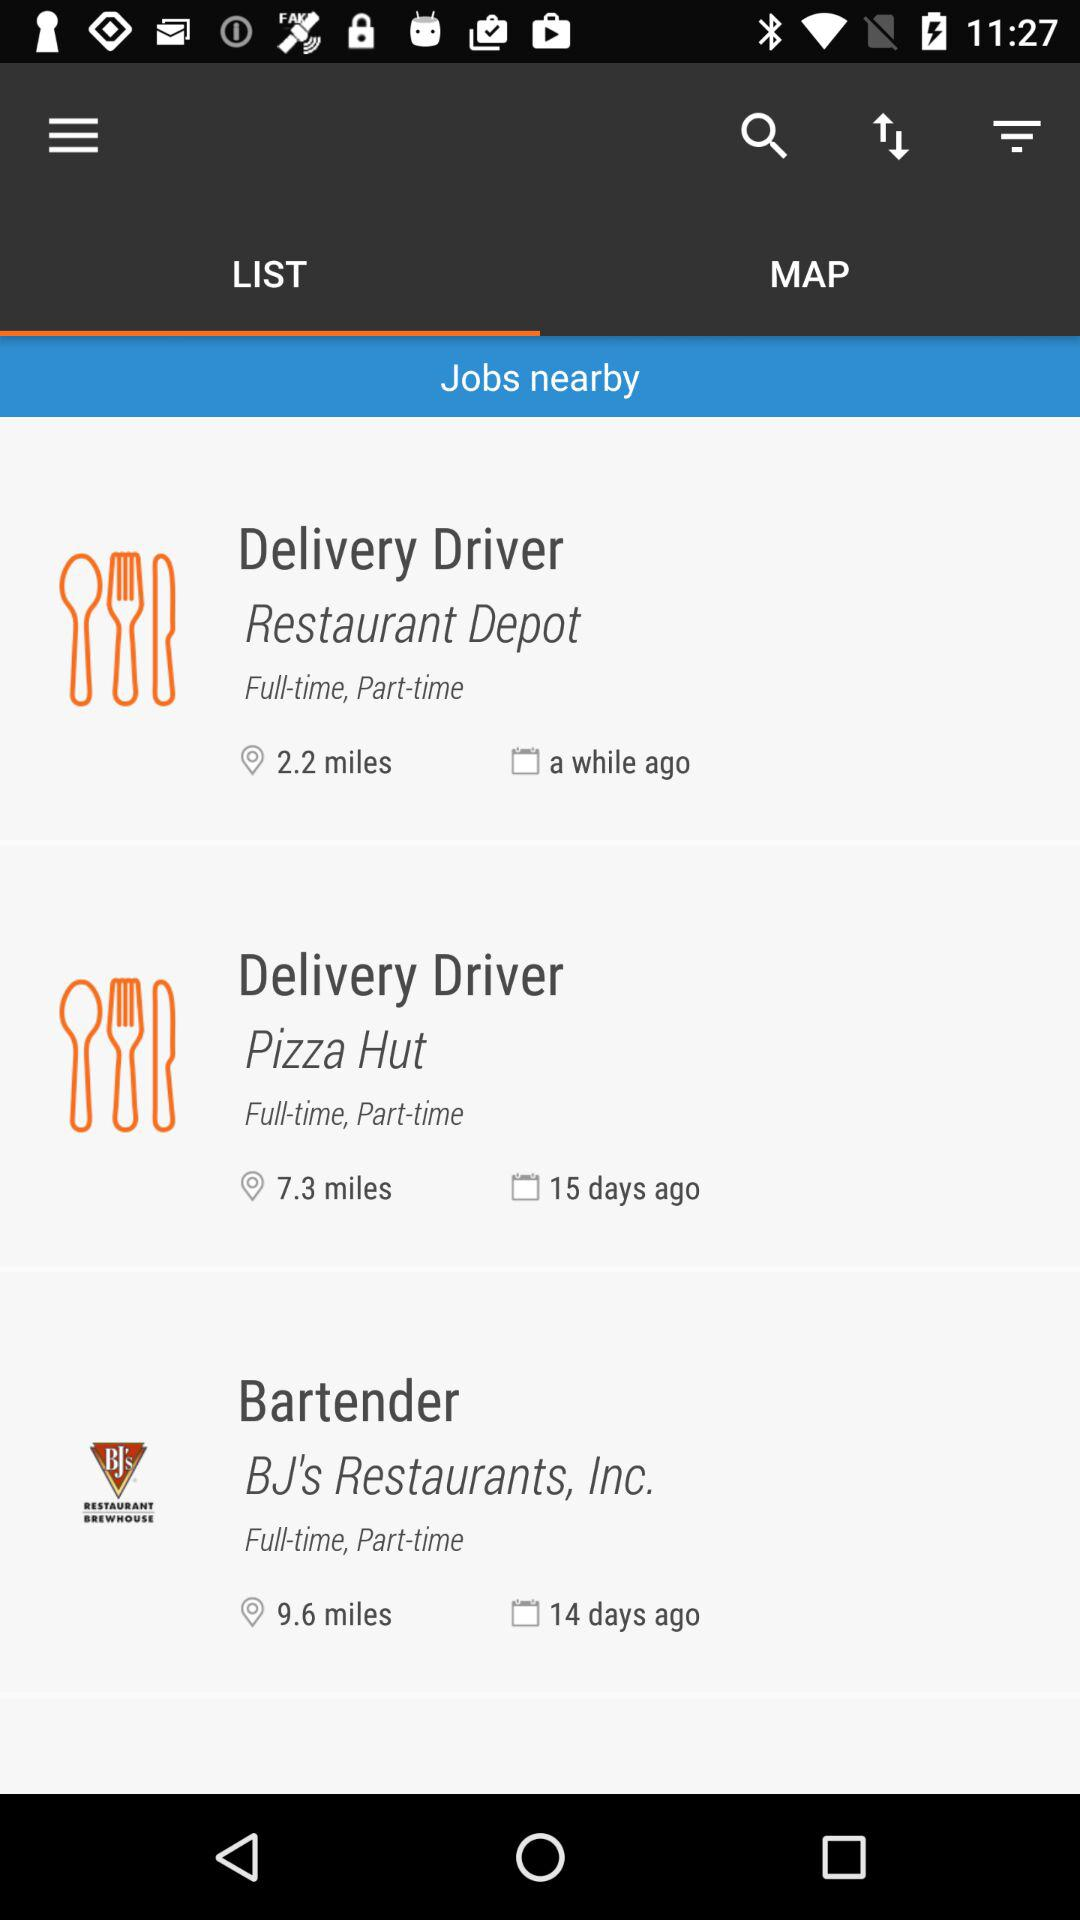How many jobs are available?
Answer the question using a single word or phrase. 3 